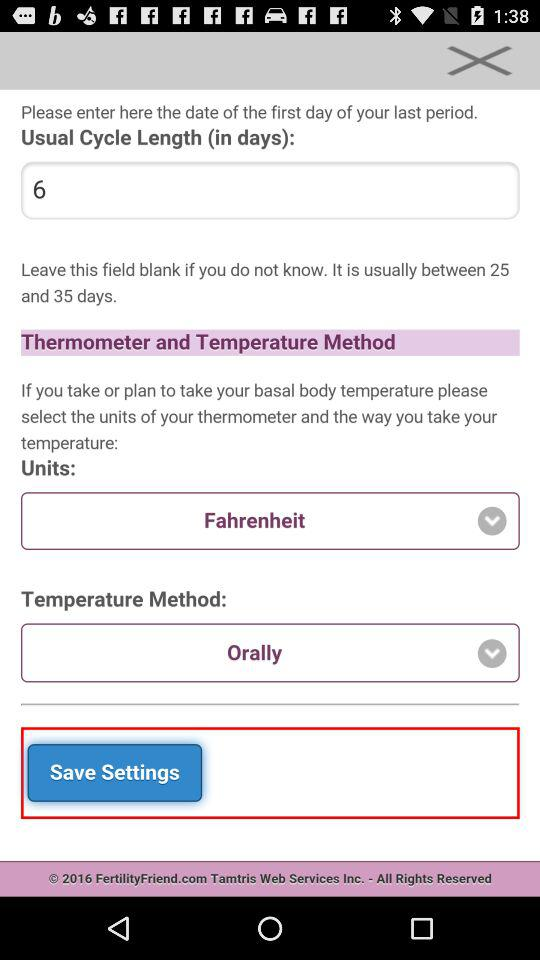Is Celsius available?
When the provided information is insufficient, respond with <no answer>. <no answer> 